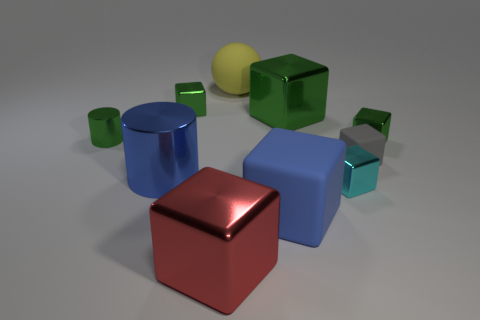How many green blocks must be subtracted to get 1 green blocks? 2 Subtract all gray spheres. How many green blocks are left? 3 Subtract all cyan cubes. How many cubes are left? 6 Subtract all small green blocks. How many blocks are left? 5 Subtract all purple cubes. Subtract all red spheres. How many cubes are left? 7 Subtract all cylinders. How many objects are left? 8 Subtract all blue objects. Subtract all tiny blocks. How many objects are left? 4 Add 1 big green metal blocks. How many big green metal blocks are left? 2 Add 4 green spheres. How many green spheres exist? 4 Subtract 2 green cubes. How many objects are left? 8 